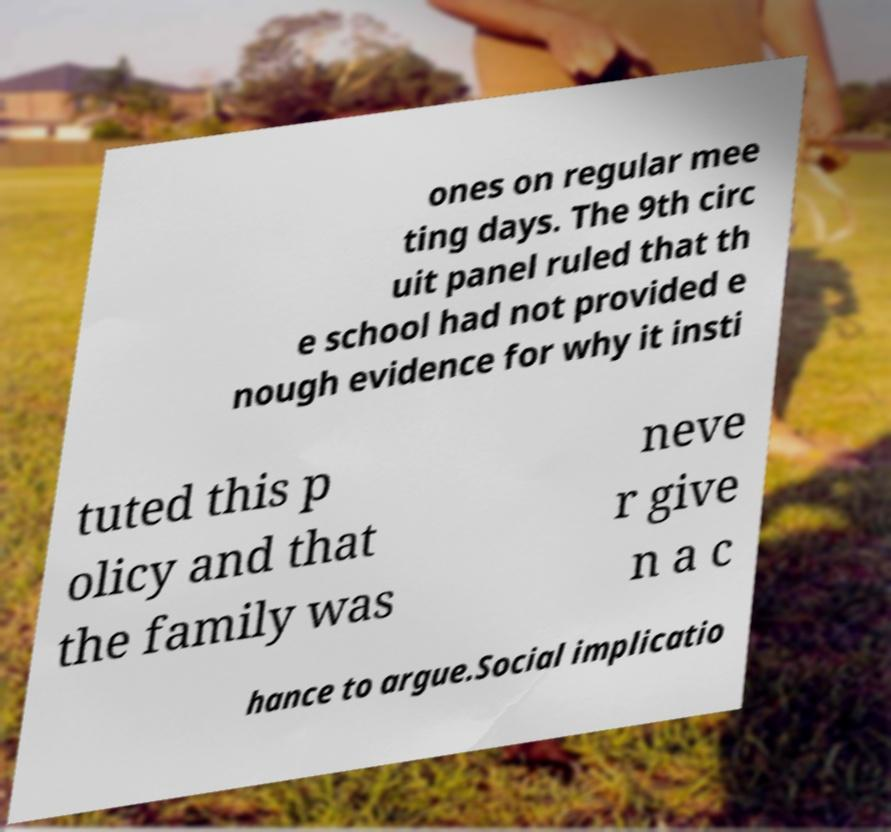What messages or text are displayed in this image? I need them in a readable, typed format. ones on regular mee ting days. The 9th circ uit panel ruled that th e school had not provided e nough evidence for why it insti tuted this p olicy and that the family was neve r give n a c hance to argue.Social implicatio 